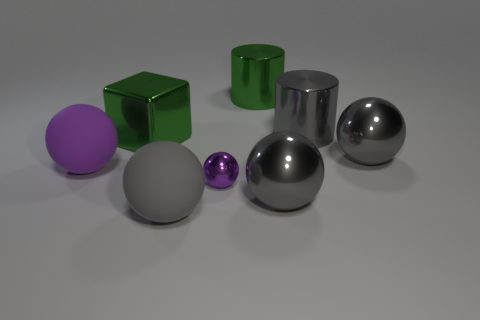Can you tell me the material that the objects might be made of based on their appearance? The objects in the image appear to be constructed from various materials based on their surfaces and reflections. The shiny balls and the cube could be made of polished metal due to their mirror-like reflections. On the other hand, the matte surfaces of the purple and green spheres suggest a plastic or painted material with less reflective qualities. 